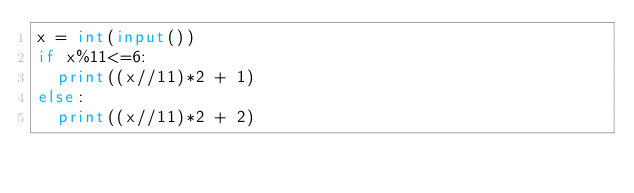Convert code to text. <code><loc_0><loc_0><loc_500><loc_500><_Python_>x = int(input())
if x%11<=6:
  print((x//11)*2 + 1)
else:
  print((x//11)*2 + 2)
</code> 